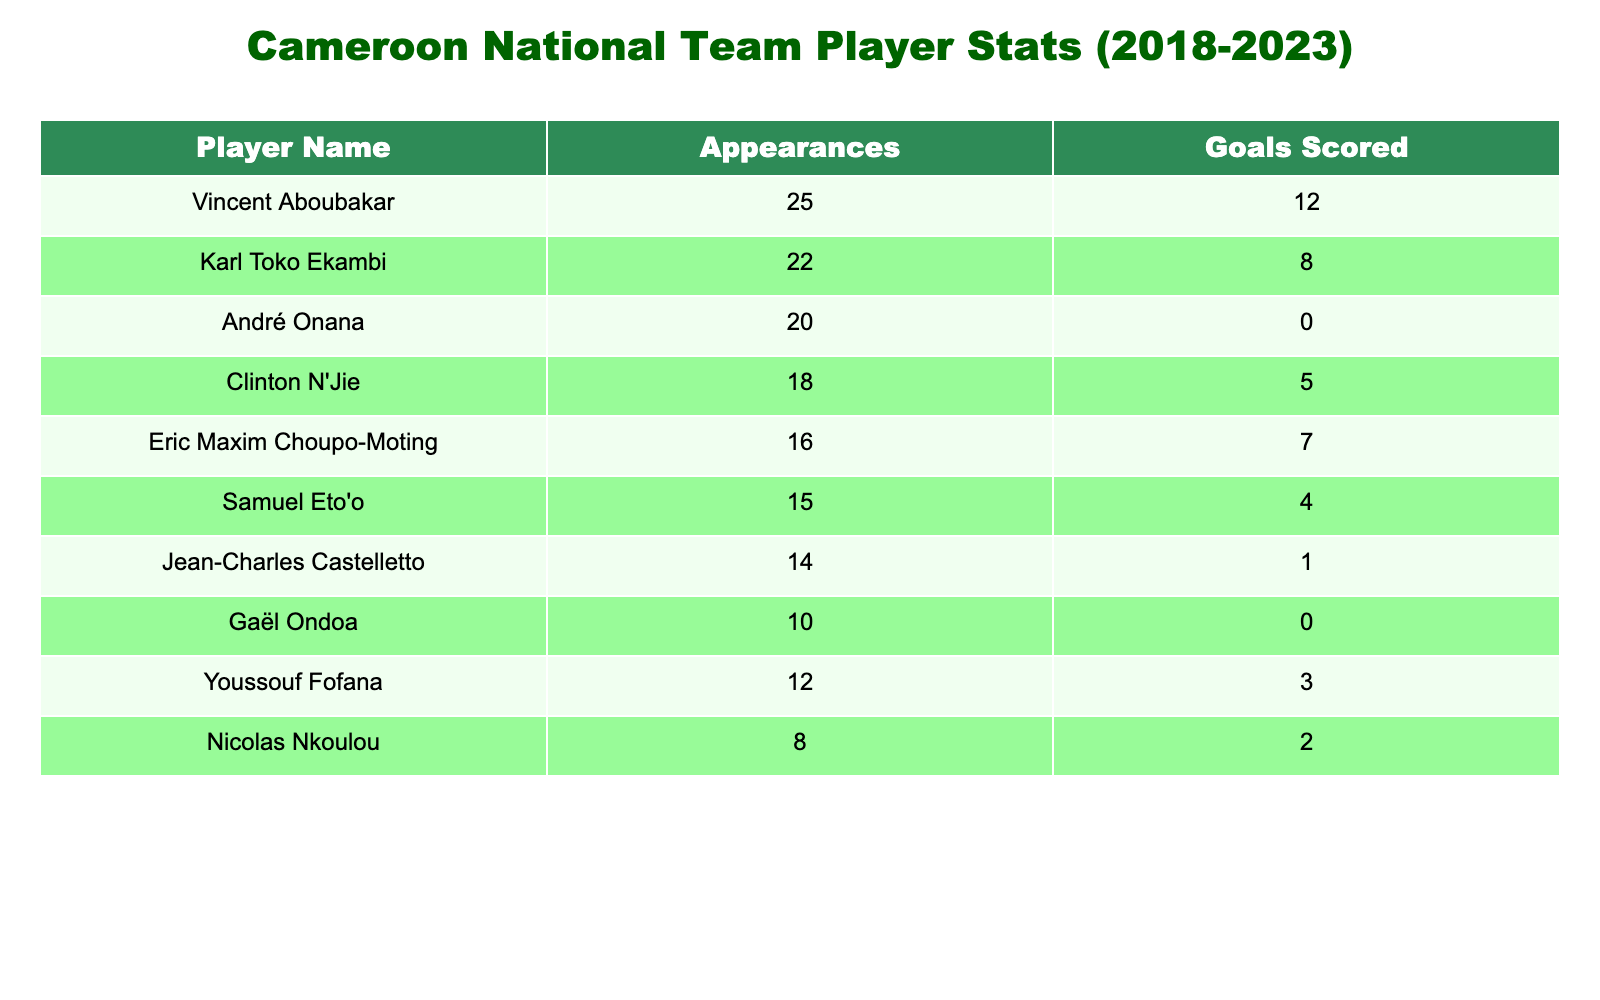What is the total number of goals scored by all players combined? To find the total number of goals, we sum the 'Goals Scored' column. The individual goal contributions are: 12 + 8 + 0 + 5 + 7 + 4 + 1 + 0 + 3 + 2 = 42. Thus, the total number of goals scored is 42.
Answer: 42 Which player has the highest number of appearances? The 'Appearances' column shows the values: 25, 22, 20, 18, 16, 15, 14, 10, 12, and 8. The highest value is 25, which belongs to Vincent Aboubakar.
Answer: Vincent Aboubakar How many players scored 0 goals? By reviewing the 'Goals Scored' column, the players with '0' goals are André Onana and Gaël Ondoa. There are two players in total who scored 0 goals.
Answer: 2 What is the average number of goals scored per appearance across all players? To find the average goals per appearance, first, we calculate the total goals (42) and total appearances (the sum is 25 + 22 + 20 + 18 + 16 + 15 + 14 + 10 + 12 + 8 =  250). Then we divide the total goals by total appearances: 42 / 250 = 0.168. Thus, the average number of goals scored per appearance is approximately 0.17.
Answer: 0.17 Is Clinton N'Jie among the top three players with the most goals scored in this table? To determine this, we list the goals scored: 12, 8, 7, 5, 4, 3, 2, 1, 0. The top three players based on goals are Vincent Aboubakar (12), Karl Toko Ekambi (8), and Eric Maxim Choupo-Moting (7). Since Clinton N'Jie scored 5, he is not among the top three.
Answer: No How many players scored more than 5 goals? By examining the 'Goals Scored' column, the players who scored more than 5 goals are Vincent Aboubakar (12), Karl Toko Ekambi (8), and Eric Maxim Choupo-Moting (7). This amounts to three players.
Answer: 3 What is the difference in appearances between the player with the most and the player with the least? The player with the most appearances is Vincent Aboubakar with 25, while the player with the least is Nicolas Nkoulou with 8. The difference is 25 - 8 = 17.
Answer: 17 How many players had more appearances than goals? Counting from the data, we see that André Onana (20 appearances, 0 goals), Clinton N'Jie (18 appearances, 5 goals), Eric Maxim Choupo-Moting (16 appearances, 7 goals), Samuel Eto'o (15 appearances, 4 goals), Jean-Charles Castelletto (14 appearances, 1 goal), and Gaël Ondoa (10 appearances, 0 goals) all had more appearances than goals. This gives us a total of six players.
Answer: 6 